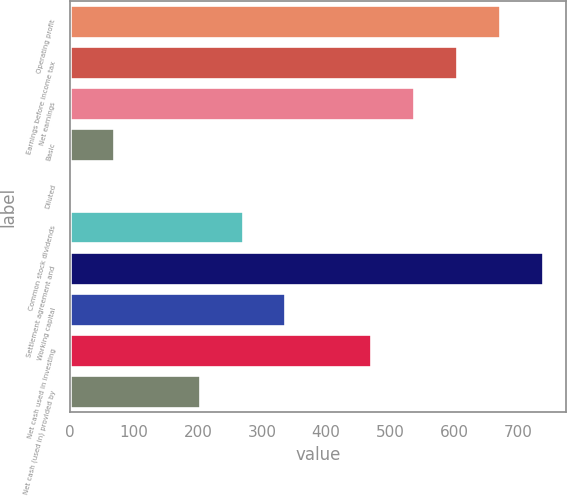Convert chart to OTSL. <chart><loc_0><loc_0><loc_500><loc_500><bar_chart><fcel>Operating profit<fcel>Earnings before income tax<fcel>Net earnings<fcel>Basic<fcel>Diluted<fcel>Common stock dividends<fcel>Settlement agreement and<fcel>Working capital<fcel>Net cash used in investing<fcel>Net cash (used in) provided by<nl><fcel>670.88<fcel>603.98<fcel>537.08<fcel>68.78<fcel>1.88<fcel>269.48<fcel>737.78<fcel>336.38<fcel>470.18<fcel>202.58<nl></chart> 